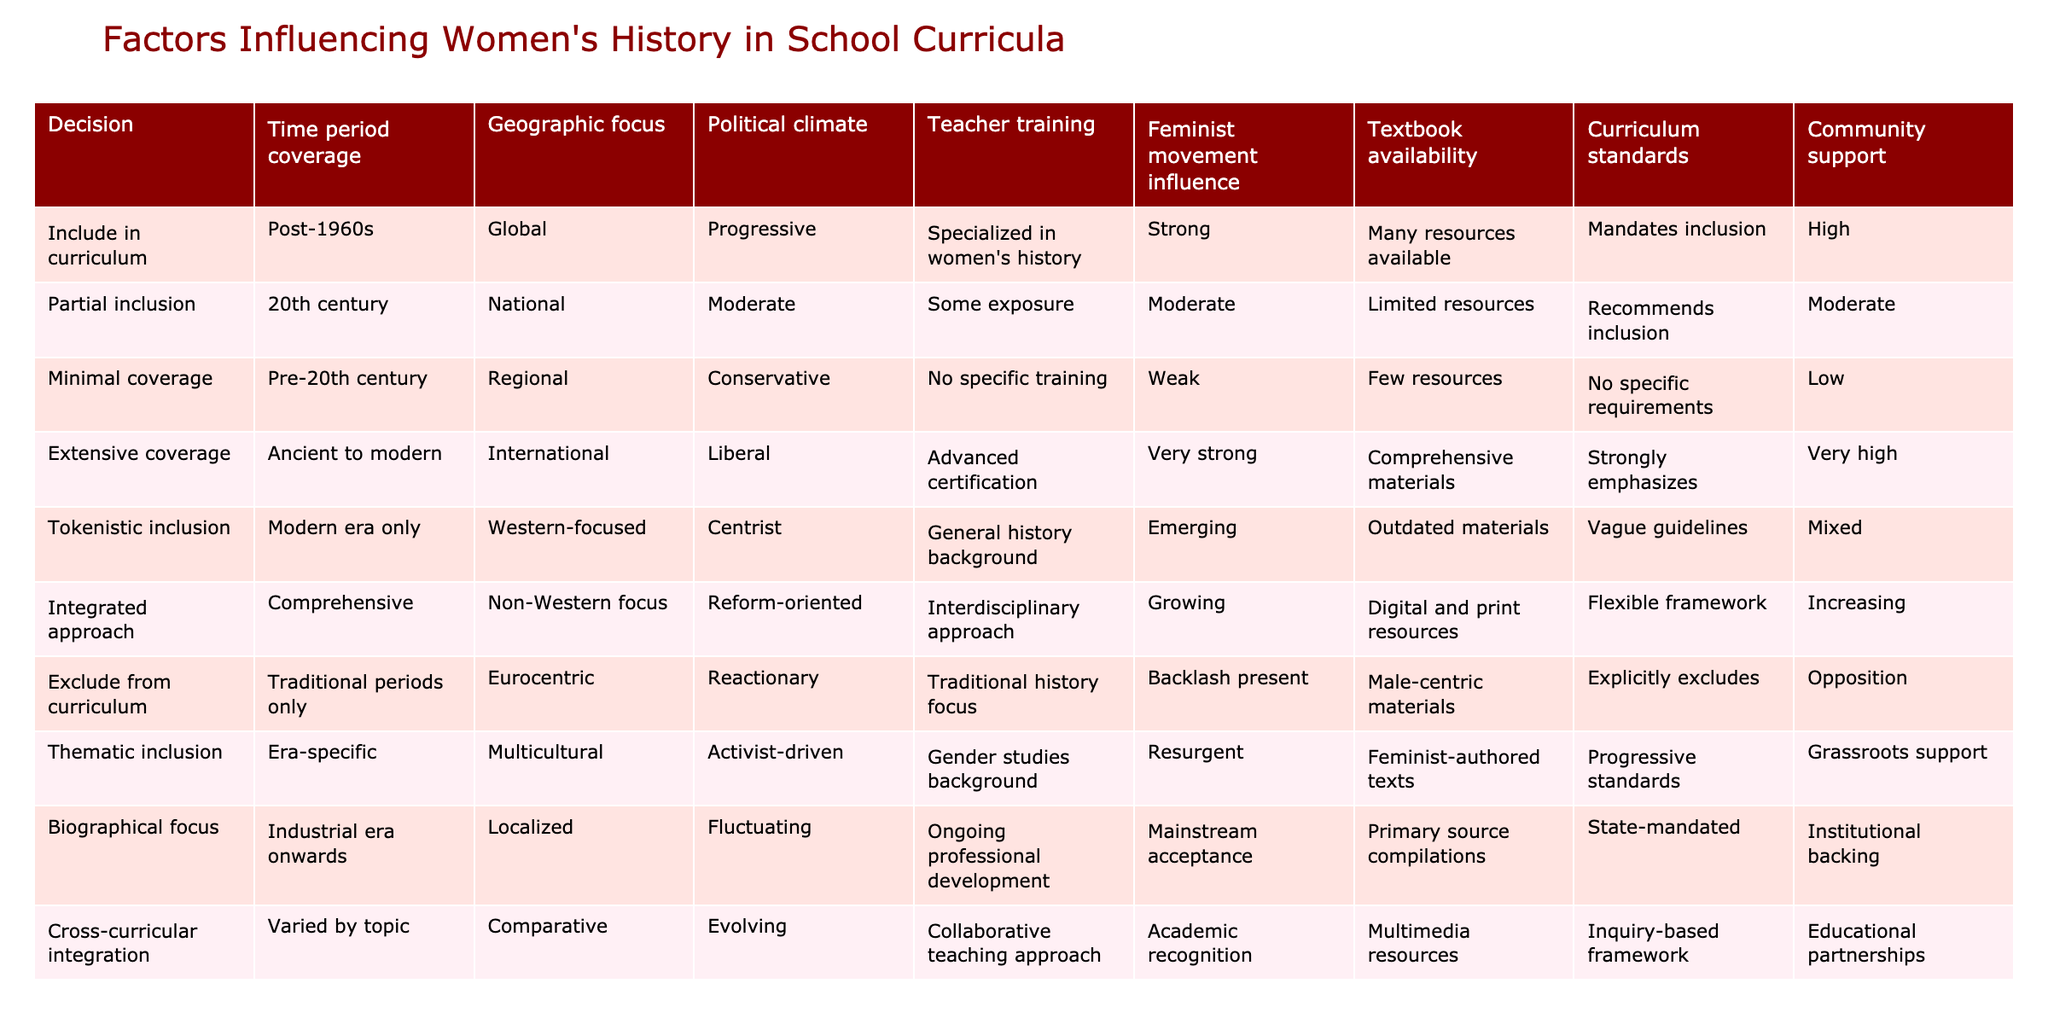What is the geographic focus of the "Extensive coverage" decision? The table lists the geographic focus for the "Extensive coverage" decision as "International". This can be directly retrieved from the corresponding row in the table.
Answer: International How many decisions are characterized by "Progressive" political climate? By examining the table, the decisions that have a "Progressive" political climate are "Include in curriculum", "Thematic inclusion", and "Cross-curricular integration". This results in a total of 3 decisions.
Answer: 3 Is there any decision that has "Weak" community support? The "Minimal coverage" decision has "Weak" community support according to the table. This is a direct retrieval of information from the corresponding row.
Answer: Yes What is the average level of teacher training across all decisions? The levels of teacher training given are: "Specialized in women's history", "Some exposure", "No specific training", "Advanced certification", "General history background", "Interdisciplinary approach", "Ongoing professional development", "Collaborative teaching approach". These are qualitative rather than quantitative, so we interpret them as a range from "No specific training" (1) to "Advanced certification" (4). Converting them gives approximate values: [2.5, 1, 0, 4, 2, 3, 2, 3]. Summing them gives 18, divided by 8 results in an average of 2.25 on this qualitative scale, which can be interpreted as low to moderate training.
Answer: Approximately 2.25 How does the "Feminist movement influence" vary among the different decisions? Looking at the table, the influences are categorized as follows: "Strong", "Moderate", "Weak", "Very strong", "Emerging", "Growing", "Resurgent", and "Mainstream acceptance". The variation indicates that decisions span from minimal influence to a very strong present influence, showing a clear range from weak to strong.
Answer: Varies from weak to very strong 